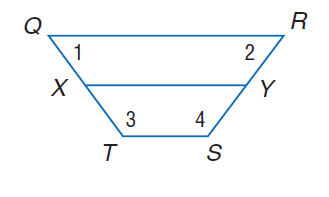Question: Q R S T is an isosceles trapezoid with median X Y. Find T S if Q R = 22 and X Y = 15.
Choices:
A. 2
B. 4
C. 8
D. 16
Answer with the letter. Answer: C 